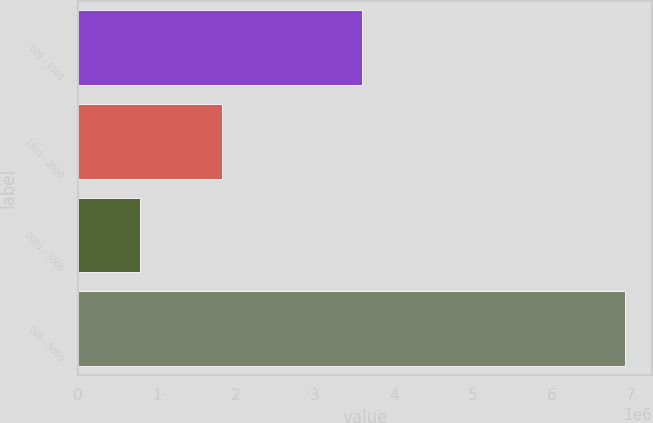Convert chart to OTSL. <chart><loc_0><loc_0><loc_500><loc_500><bar_chart><fcel>000 - 1000<fcel>1001 - 2000<fcel>2001 - 3000<fcel>000 - 5000<nl><fcel>3.59954e+06<fcel>1.81882e+06<fcel>779719<fcel>6.92008e+06<nl></chart> 